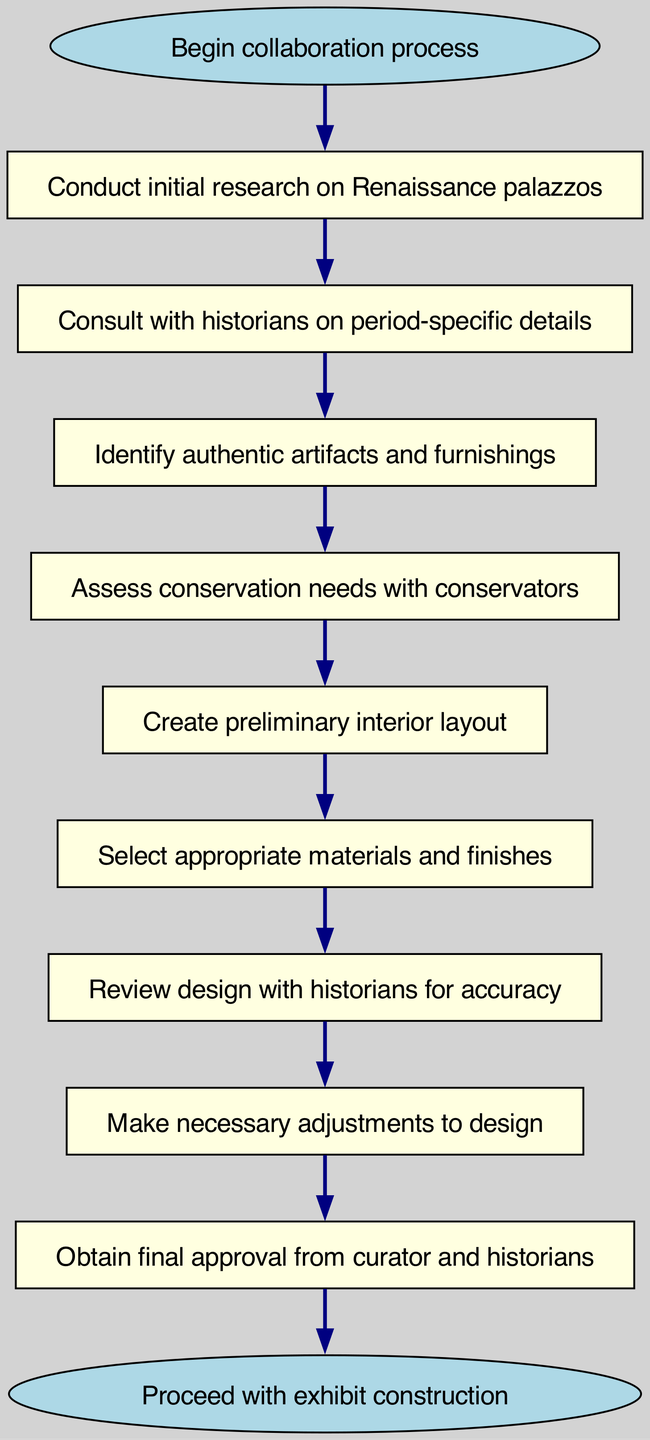What is the first step in the collaboration process? The first step in the flowchart is indicated by the "Begin collaboration process" node. This node represents the initiation of the entire process described in the diagram.
Answer: Begin collaboration process How many nodes are there in total? By counting all the nodes listed in the diagram—both the start and end nodes included—there are 11 nodes in total.
Answer: 11 What follows after conducting initial research on Renaissance palazzos? The diagram shows that the next step, after conducting initial research, is to "Consult with historians on period-specific details." This is the direct connection following the research phase.
Answer: Consult with historians on period-specific details Which step involves assessing conservation needs? Referring to the diagram, the step that involves assessing conservation needs is labeled "Assess conservation needs with conservators." It comes directly after identifying artifacts and furnishings.
Answer: Assess conservation needs with conservators What is the last step before proceeding with exhibit construction? The flowchart indicates that the last step before proceeding with exhibit construction is "Obtain final approval from curator and historians." This is the second-to-last step in the sequence.
Answer: Obtain final approval from curator and historians How many steps are there from identifying artifacts to final approval? To find the number of steps, you can trace from "Identify authentic artifacts and furnishings" to "Obtain final approval from curator and historians," passing through four distinct steps along the way.
Answer: 4 What is the relationship between designing the layout and selecting materials? According to the diagram, "Create preliminary interior layout" directly leads into the step of "Select appropriate materials and finishes," indicating a sequential relationship between designing and material selection.
Answer: Create preliminary interior layout leads to Select appropriate materials and finishes Which node is connected to both "Assess conservation needs with conservators" and "Create preliminary interior layout"? The flowchart illustrates that the node "Identify authentic artifacts and furnishings" is the connecting node that leads to both "Assess conservation needs with conservators" and "Create preliminary interior layout."
Answer: Identify authentic artifacts and furnishings What is the significance of the node labeled "Review design with historians for accuracy"? This node represents a critical verification stage in the process, where historians review the created design to ensure its accuracy relative to historical details. This step emphasizes collaboration and historical authenticity.
Answer: Review design with historians for accuracy 